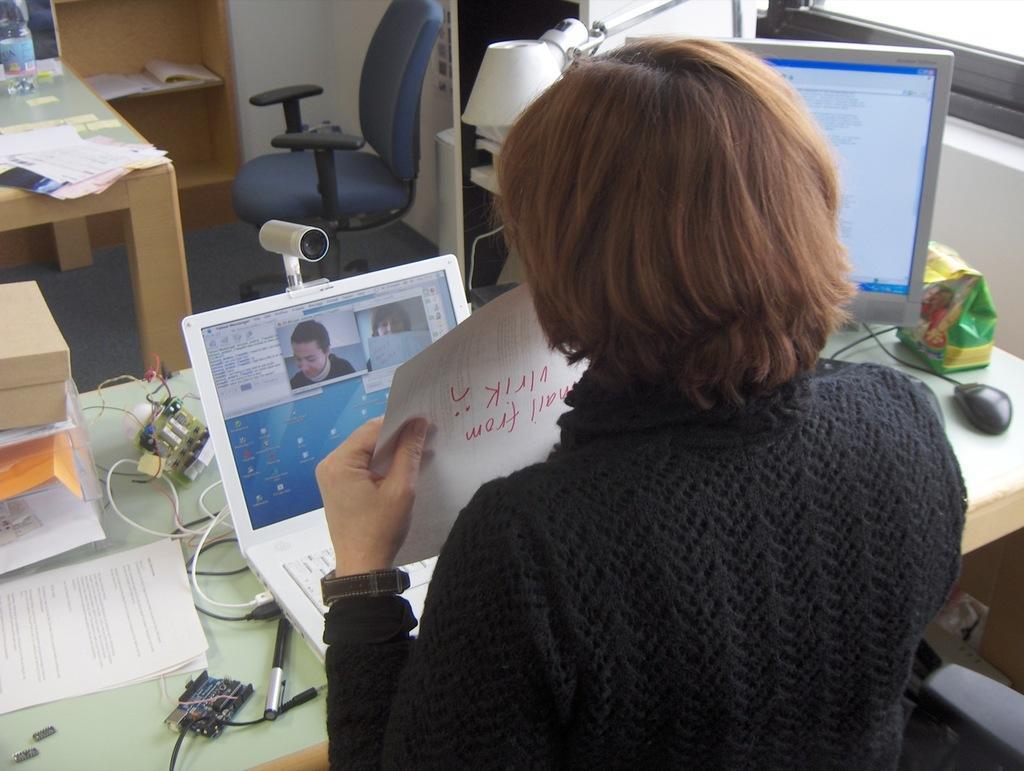How would you summarize this image in a sentence or two? In this image I can see a person is in front of the table. On the table there is a system,laptop,papers,books and some of the objects. In the background there is a chair and the cupboard. 